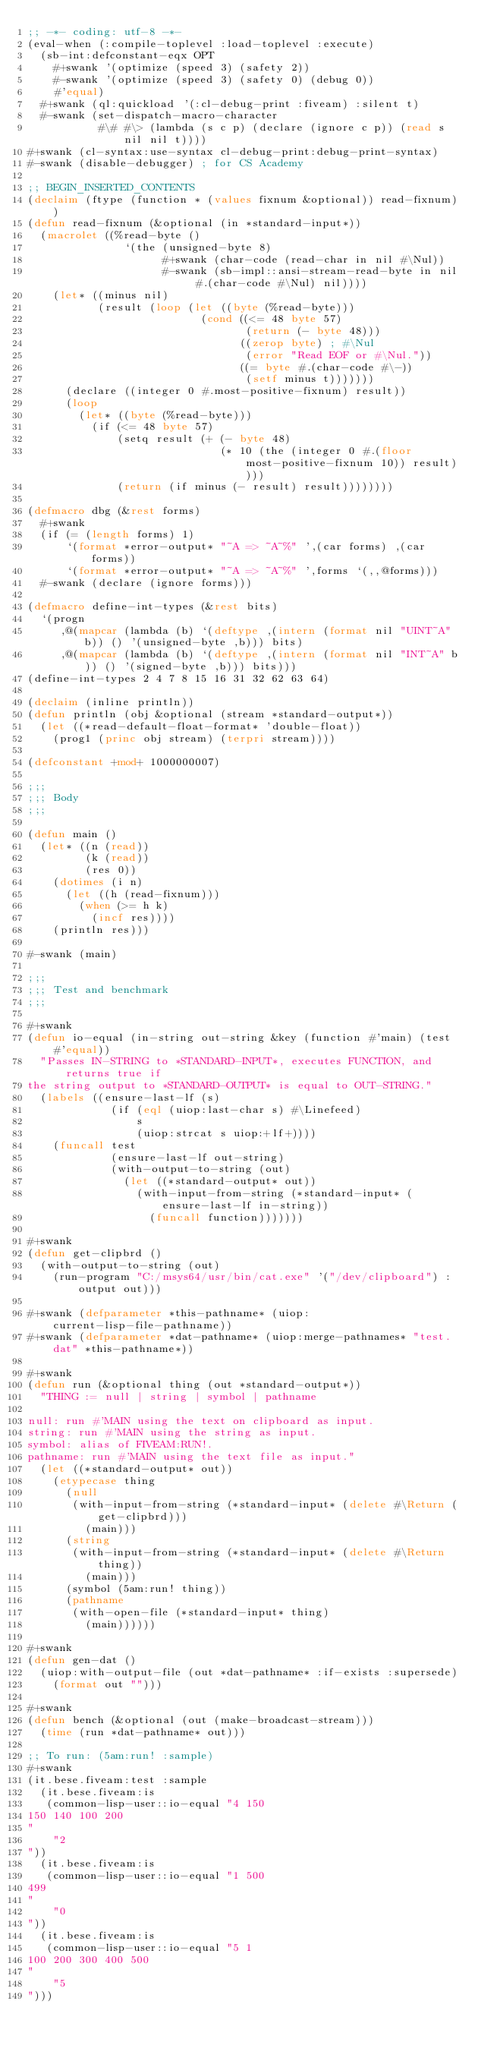<code> <loc_0><loc_0><loc_500><loc_500><_Lisp_>;; -*- coding: utf-8 -*-
(eval-when (:compile-toplevel :load-toplevel :execute)
  (sb-int:defconstant-eqx OPT
    #+swank '(optimize (speed 3) (safety 2))
    #-swank '(optimize (speed 3) (safety 0) (debug 0))
    #'equal)
  #+swank (ql:quickload '(:cl-debug-print :fiveam) :silent t)
  #-swank (set-dispatch-macro-character
           #\# #\> (lambda (s c p) (declare (ignore c p)) (read s nil nil t))))
#+swank (cl-syntax:use-syntax cl-debug-print:debug-print-syntax)
#-swank (disable-debugger) ; for CS Academy

;; BEGIN_INSERTED_CONTENTS
(declaim (ftype (function * (values fixnum &optional)) read-fixnum))
(defun read-fixnum (&optional (in *standard-input*))
  (macrolet ((%read-byte ()
               `(the (unsigned-byte 8)
                     #+swank (char-code (read-char in nil #\Nul))
                     #-swank (sb-impl::ansi-stream-read-byte in nil #.(char-code #\Nul) nil))))
    (let* ((minus nil)
           (result (loop (let ((byte (%read-byte)))
                           (cond ((<= 48 byte 57)
                                  (return (- byte 48)))
                                 ((zerop byte) ; #\Nul
                                  (error "Read EOF or #\Nul."))
                                 ((= byte #.(char-code #\-))
                                  (setf minus t)))))))
      (declare ((integer 0 #.most-positive-fixnum) result))
      (loop
        (let* ((byte (%read-byte)))
          (if (<= 48 byte 57)
              (setq result (+ (- byte 48)
                              (* 10 (the (integer 0 #.(floor most-positive-fixnum 10)) result))))
              (return (if minus (- result) result))))))))

(defmacro dbg (&rest forms)
  #+swank
  (if (= (length forms) 1)
      `(format *error-output* "~A => ~A~%" ',(car forms) ,(car forms))
      `(format *error-output* "~A => ~A~%" ',forms `(,,@forms)))
  #-swank (declare (ignore forms)))

(defmacro define-int-types (&rest bits)
  `(progn
     ,@(mapcar (lambda (b) `(deftype ,(intern (format nil "UINT~A" b)) () '(unsigned-byte ,b))) bits)
     ,@(mapcar (lambda (b) `(deftype ,(intern (format nil "INT~A" b)) () '(signed-byte ,b))) bits)))
(define-int-types 2 4 7 8 15 16 31 32 62 63 64)

(declaim (inline println))
(defun println (obj &optional (stream *standard-output*))
  (let ((*read-default-float-format* 'double-float))
    (prog1 (princ obj stream) (terpri stream))))

(defconstant +mod+ 1000000007)

;;;
;;; Body
;;;

(defun main ()
  (let* ((n (read))
         (k (read))
         (res 0))
    (dotimes (i n)
      (let ((h (read-fixnum)))
        (when (>= h k)
          (incf res))))
    (println res)))

#-swank (main)

;;;
;;; Test and benchmark
;;;

#+swank
(defun io-equal (in-string out-string &key (function #'main) (test #'equal))
  "Passes IN-STRING to *STANDARD-INPUT*, executes FUNCTION, and returns true if
the string output to *STANDARD-OUTPUT* is equal to OUT-STRING."
  (labels ((ensure-last-lf (s)
             (if (eql (uiop:last-char s) #\Linefeed)
                 s
                 (uiop:strcat s uiop:+lf+))))
    (funcall test
             (ensure-last-lf out-string)
             (with-output-to-string (out)
               (let ((*standard-output* out))
                 (with-input-from-string (*standard-input* (ensure-last-lf in-string))
                   (funcall function)))))))

#+swank
(defun get-clipbrd ()
  (with-output-to-string (out)
    (run-program "C:/msys64/usr/bin/cat.exe" '("/dev/clipboard") :output out)))

#+swank (defparameter *this-pathname* (uiop:current-lisp-file-pathname))
#+swank (defparameter *dat-pathname* (uiop:merge-pathnames* "test.dat" *this-pathname*))

#+swank
(defun run (&optional thing (out *standard-output*))
  "THING := null | string | symbol | pathname

null: run #'MAIN using the text on clipboard as input.
string: run #'MAIN using the string as input.
symbol: alias of FIVEAM:RUN!.
pathname: run #'MAIN using the text file as input."
  (let ((*standard-output* out))
    (etypecase thing
      (null
       (with-input-from-string (*standard-input* (delete #\Return (get-clipbrd)))
         (main)))
      (string
       (with-input-from-string (*standard-input* (delete #\Return thing))
         (main)))
      (symbol (5am:run! thing))
      (pathname
       (with-open-file (*standard-input* thing)
         (main))))))

#+swank
(defun gen-dat ()
  (uiop:with-output-file (out *dat-pathname* :if-exists :supersede)
    (format out "")))

#+swank
(defun bench (&optional (out (make-broadcast-stream)))
  (time (run *dat-pathname* out)))

;; To run: (5am:run! :sample)
#+swank
(it.bese.fiveam:test :sample
  (it.bese.fiveam:is
   (common-lisp-user::io-equal "4 150
150 140 100 200
"
    "2
"))
  (it.bese.fiveam:is
   (common-lisp-user::io-equal "1 500
499
"
    "0
"))
  (it.bese.fiveam:is
   (common-lisp-user::io-equal "5 1
100 200 300 400 500
"
    "5
")))
</code> 